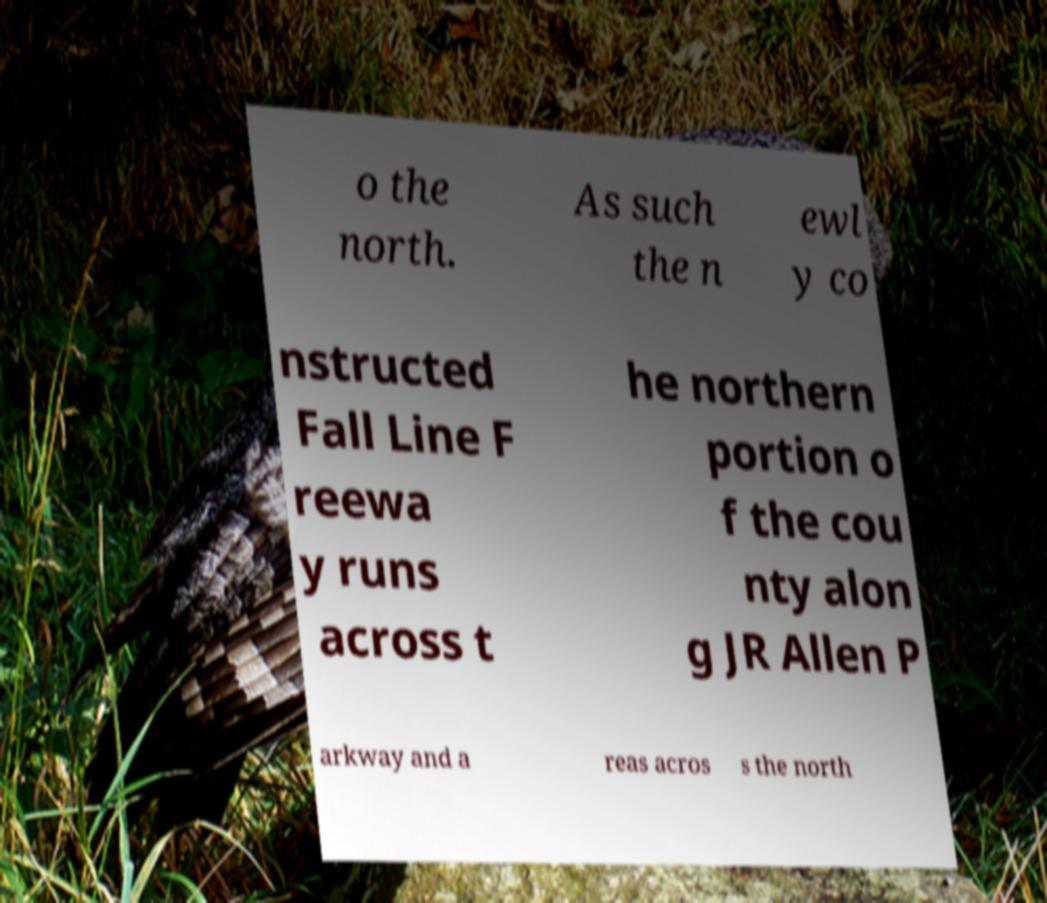For documentation purposes, I need the text within this image transcribed. Could you provide that? o the north. As such the n ewl y co nstructed Fall Line F reewa y runs across t he northern portion o f the cou nty alon g JR Allen P arkway and a reas acros s the north 